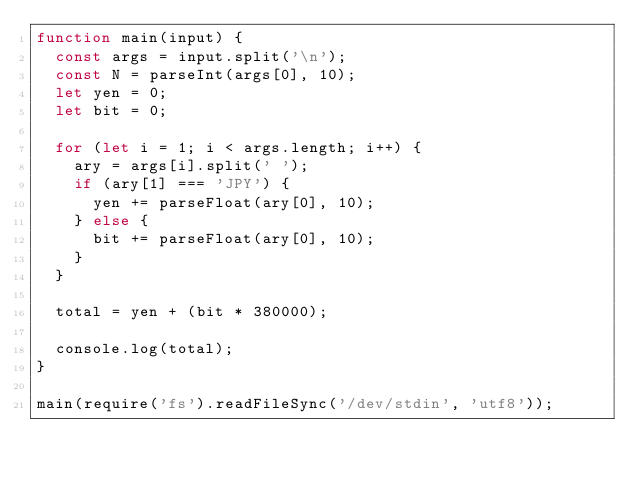<code> <loc_0><loc_0><loc_500><loc_500><_JavaScript_>function main(input) {
  const args = input.split('\n');
  const N = parseInt(args[0], 10);
  let yen = 0;
  let bit = 0;
  
  for (let i = 1; i < args.length; i++) {
    ary = args[i].split(' ');
    if (ary[1] === 'JPY') {
      yen += parseFloat(ary[0], 10);
    } else {
      bit += parseFloat(ary[0], 10);
    }
  }
  
  total = yen + (bit * 380000);
  
  console.log(total);
}

main(require('fs').readFileSync('/dev/stdin', 'utf8'));</code> 